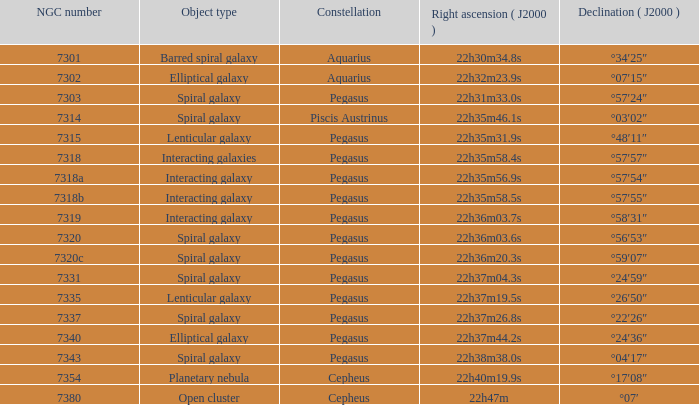What is the declination of the spiral galaxy Pegasus with 7337 NGC °22′26″. 